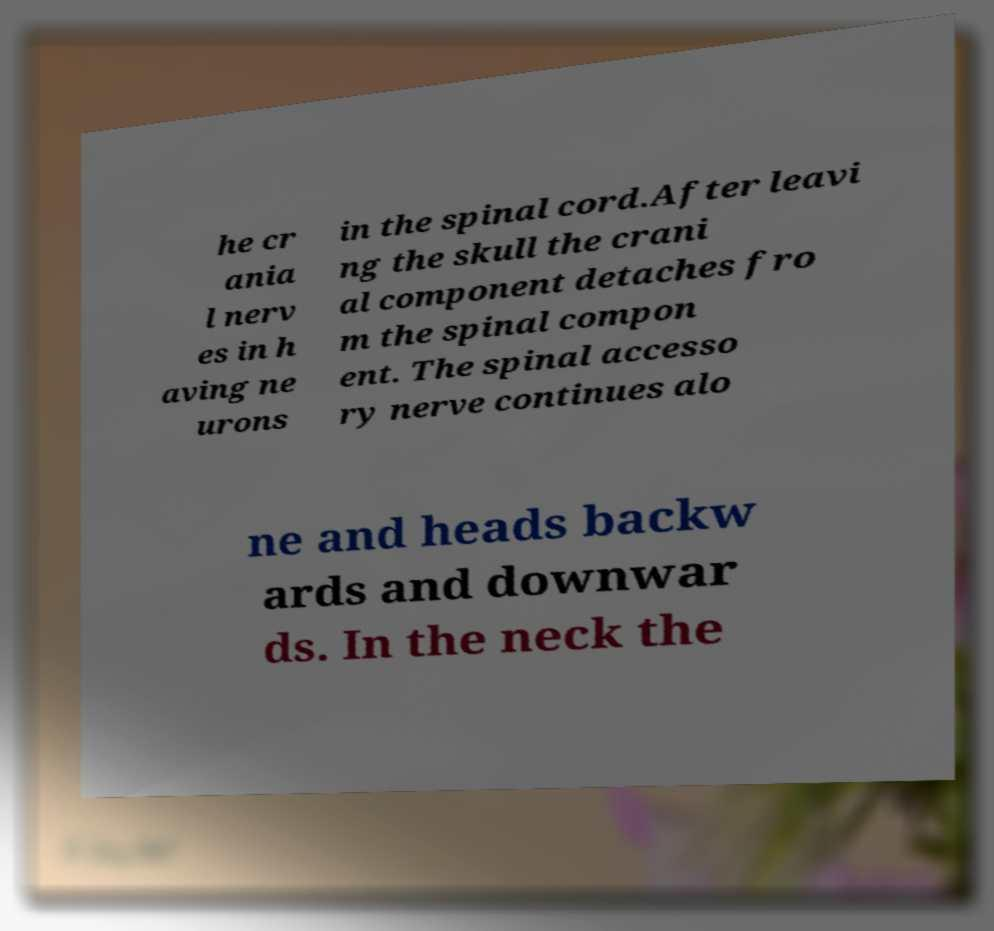I need the written content from this picture converted into text. Can you do that? he cr ania l nerv es in h aving ne urons in the spinal cord.After leavi ng the skull the crani al component detaches fro m the spinal compon ent. The spinal accesso ry nerve continues alo ne and heads backw ards and downwar ds. In the neck the 